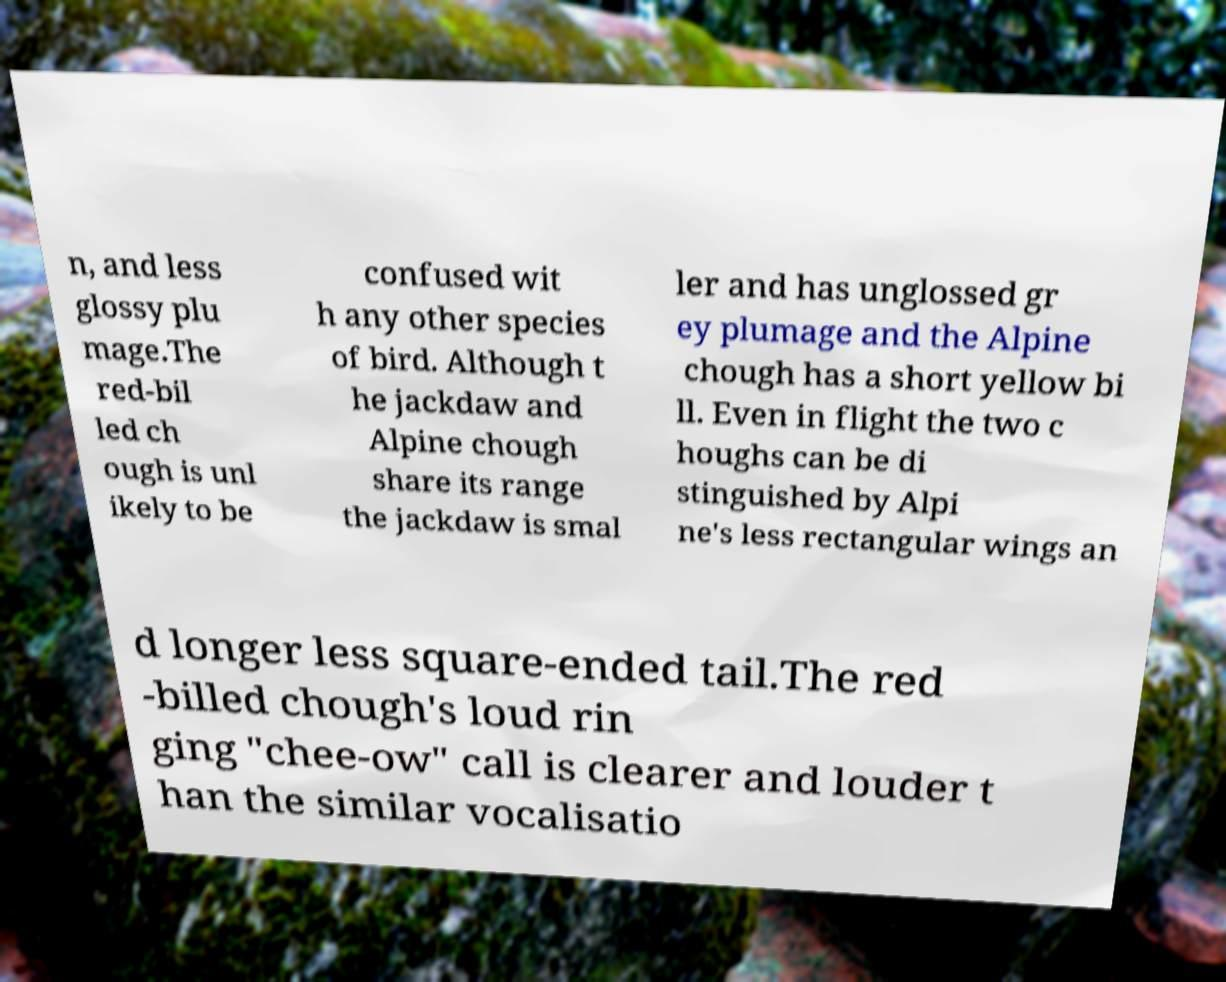Can you accurately transcribe the text from the provided image for me? n, and less glossy plu mage.The red-bil led ch ough is unl ikely to be confused wit h any other species of bird. Although t he jackdaw and Alpine chough share its range the jackdaw is smal ler and has unglossed gr ey plumage and the Alpine chough has a short yellow bi ll. Even in flight the two c houghs can be di stinguished by Alpi ne's less rectangular wings an d longer less square-ended tail.The red -billed chough's loud rin ging "chee-ow" call is clearer and louder t han the similar vocalisatio 